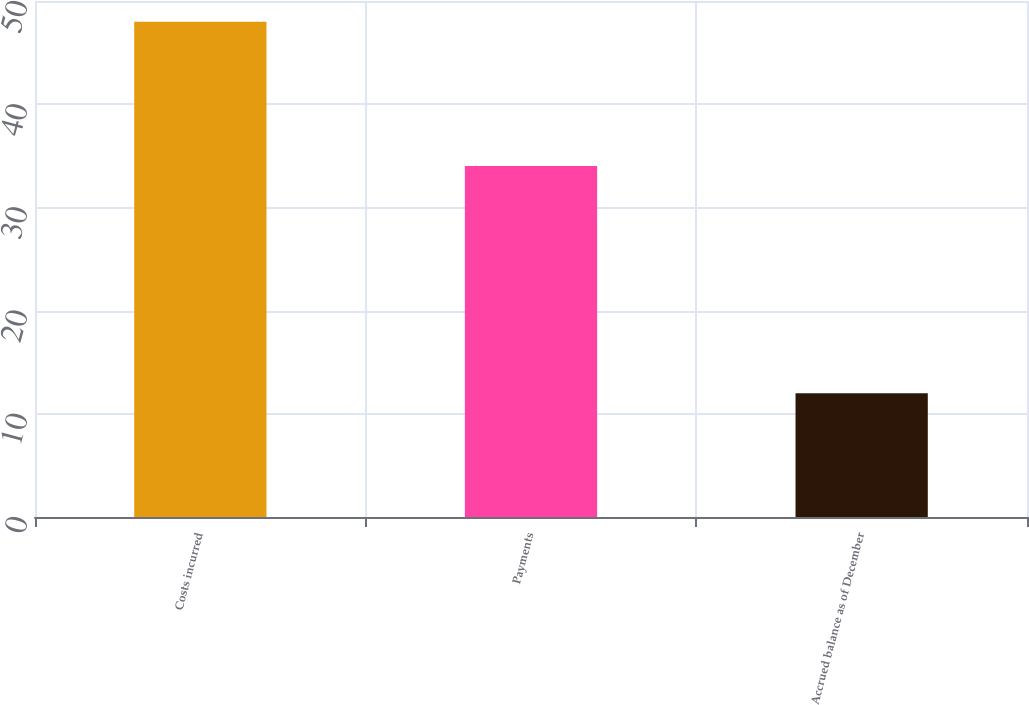Convert chart. <chart><loc_0><loc_0><loc_500><loc_500><bar_chart><fcel>Costs incurred<fcel>Payments<fcel>Accrued balance as of December<nl><fcel>48<fcel>34<fcel>12<nl></chart> 